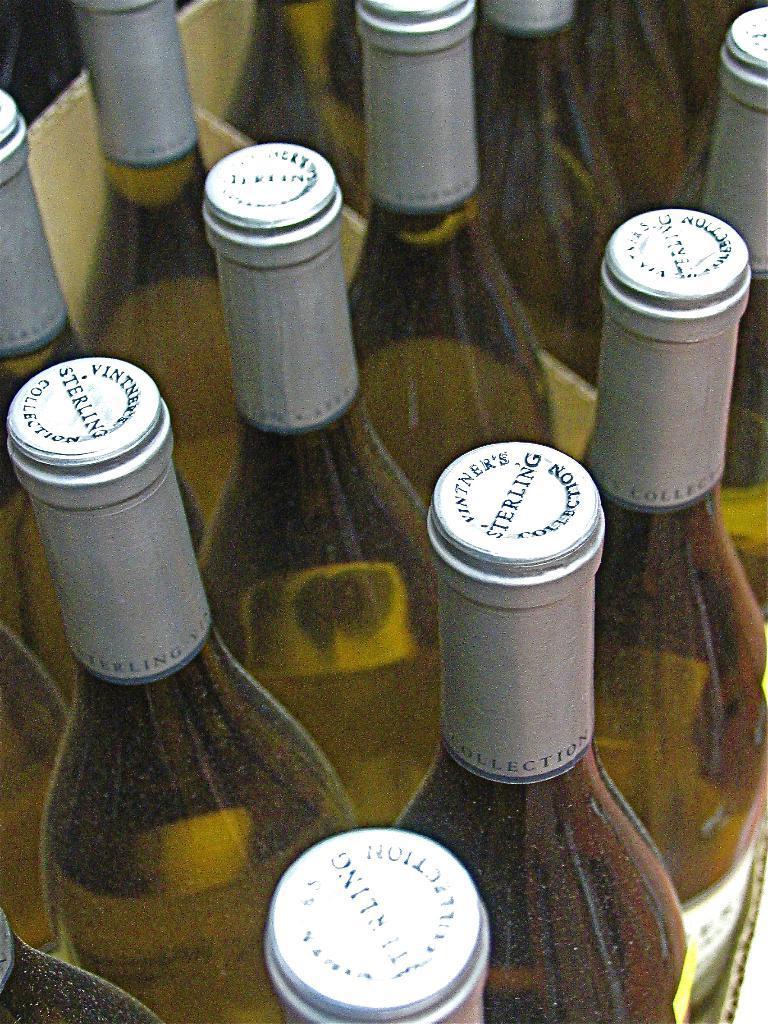How would you summarize this image in a sentence or two? In this image there are a few bottles are arranged in a carton box. 